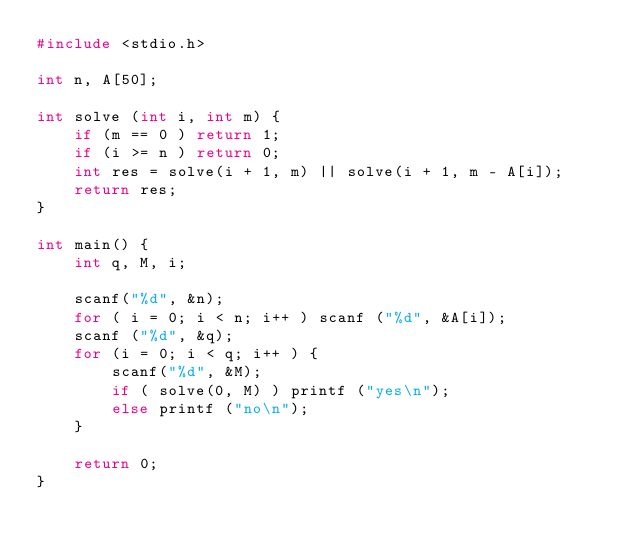<code> <loc_0><loc_0><loc_500><loc_500><_C_>#include <stdio.h>

int n, A[50];

int solve (int i, int m) {
	if (m == 0 ) return 1;
	if (i >= n ) return 0;
	int res = solve(i + 1, m) || solve(i + 1, m - A[i]);
	return res;
}

int main() {
	int q, M, i;
	
	scanf("%d", &n);
	for ( i = 0; i < n; i++ ) scanf ("%d", &A[i]);
	scanf ("%d", &q);
	for (i = 0; i < q; i++ ) {
		scanf("%d", &M);
		if ( solve(0, M) ) printf ("yes\n");
		else printf ("no\n");
	}
	
	return 0;
}
</code> 